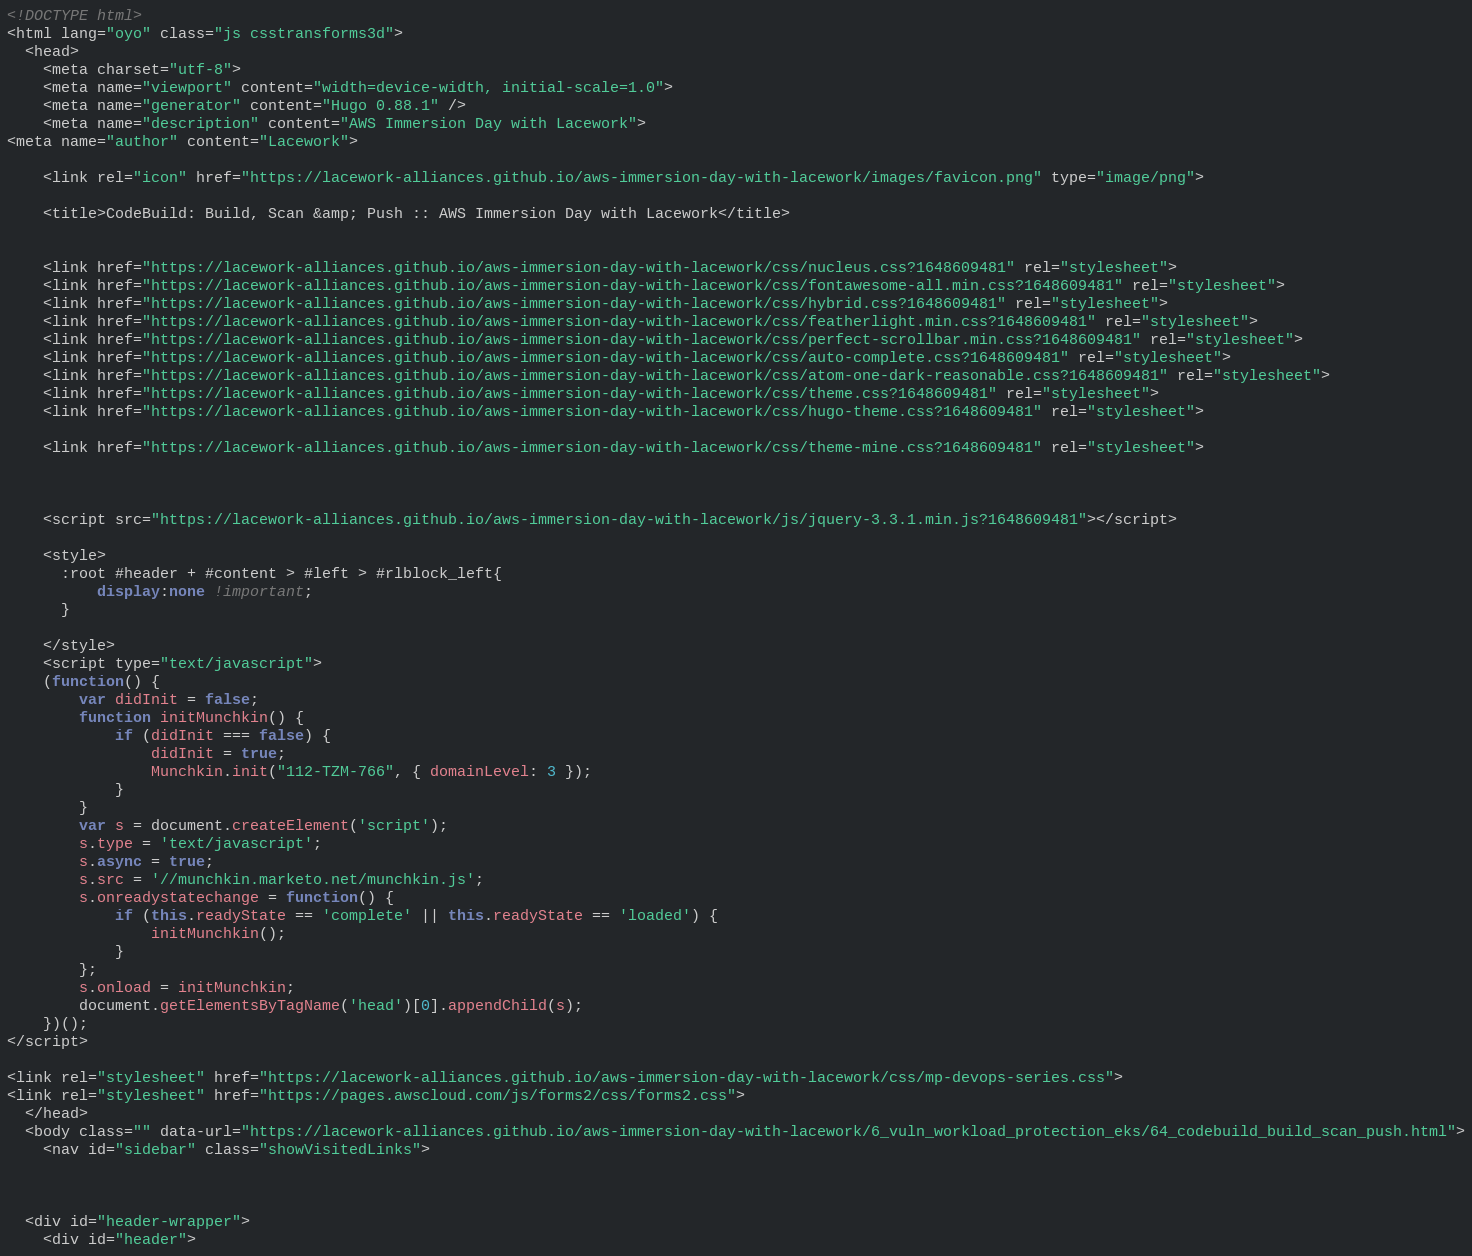<code> <loc_0><loc_0><loc_500><loc_500><_HTML_><!DOCTYPE html>
<html lang="oyo" class="js csstransforms3d">
  <head>
    <meta charset="utf-8">
    <meta name="viewport" content="width=device-width, initial-scale=1.0">
    <meta name="generator" content="Hugo 0.88.1" />
    <meta name="description" content="AWS Immersion Day with Lacework">
<meta name="author" content="Lacework">

    <link rel="icon" href="https://lacework-alliances.github.io/aws-immersion-day-with-lacework/images/favicon.png" type="image/png">

    <title>CodeBuild: Build, Scan &amp; Push :: AWS Immersion Day with Lacework</title>

    
    <link href="https://lacework-alliances.github.io/aws-immersion-day-with-lacework/css/nucleus.css?1648609481" rel="stylesheet">
    <link href="https://lacework-alliances.github.io/aws-immersion-day-with-lacework/css/fontawesome-all.min.css?1648609481" rel="stylesheet">
    <link href="https://lacework-alliances.github.io/aws-immersion-day-with-lacework/css/hybrid.css?1648609481" rel="stylesheet">
    <link href="https://lacework-alliances.github.io/aws-immersion-day-with-lacework/css/featherlight.min.css?1648609481" rel="stylesheet">
    <link href="https://lacework-alliances.github.io/aws-immersion-day-with-lacework/css/perfect-scrollbar.min.css?1648609481" rel="stylesheet">
    <link href="https://lacework-alliances.github.io/aws-immersion-day-with-lacework/css/auto-complete.css?1648609481" rel="stylesheet">
    <link href="https://lacework-alliances.github.io/aws-immersion-day-with-lacework/css/atom-one-dark-reasonable.css?1648609481" rel="stylesheet">
    <link href="https://lacework-alliances.github.io/aws-immersion-day-with-lacework/css/theme.css?1648609481" rel="stylesheet">
    <link href="https://lacework-alliances.github.io/aws-immersion-day-with-lacework/css/hugo-theme.css?1648609481" rel="stylesheet">
    
    <link href="https://lacework-alliances.github.io/aws-immersion-day-with-lacework/css/theme-mine.css?1648609481" rel="stylesheet">
    
    

    <script src="https://lacework-alliances.github.io/aws-immersion-day-with-lacework/js/jquery-3.3.1.min.js?1648609481"></script>

    <style>
      :root #header + #content > #left > #rlblock_left{
          display:none !important;
      }
      
    </style>
    <script type="text/javascript">
    (function() {
        var didInit = false;
        function initMunchkin() {
            if (didInit === false) {
                didInit = true;
                Munchkin.init("112-TZM-766", { domainLevel: 3 });
            }
        }
        var s = document.createElement('script');
        s.type = 'text/javascript';
        s.async = true;
        s.src = '//munchkin.marketo.net/munchkin.js';
        s.onreadystatechange = function() {
            if (this.readyState == 'complete' || this.readyState == 'loaded') {
                initMunchkin();
            }
        };
        s.onload = initMunchkin;
        document.getElementsByTagName('head')[0].appendChild(s);
    })();
</script>

<link rel="stylesheet" href="https://lacework-alliances.github.io/aws-immersion-day-with-lacework/css/mp-devops-series.css">
<link rel="stylesheet" href="https://pages.awscloud.com/js/forms2/css/forms2.css">
  </head>
  <body class="" data-url="https://lacework-alliances.github.io/aws-immersion-day-with-lacework/6_vuln_workload_protection_eks/64_codebuild_build_scan_push.html">
    <nav id="sidebar" class="showVisitedLinks">



  <div id="header-wrapper">
    <div id="header"></code> 